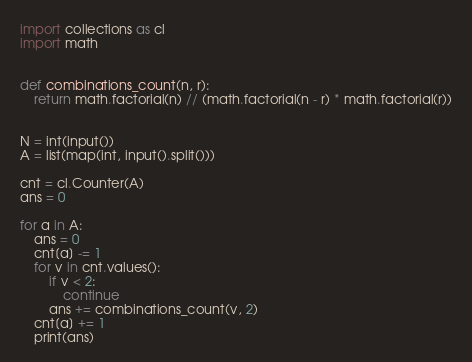<code> <loc_0><loc_0><loc_500><loc_500><_Python_>import collections as cl
import math


def combinations_count(n, r):
    return math.factorial(n) // (math.factorial(n - r) * math.factorial(r))


N = int(input())
A = list(map(int, input().split()))

cnt = cl.Counter(A)
ans = 0

for a in A:
    ans = 0
    cnt[a] -= 1
    for v in cnt.values():
        if v < 2:
            continue
        ans += combinations_count(v, 2)
    cnt[a] += 1
    print(ans)
</code> 